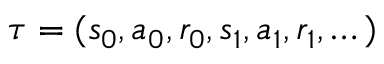<formula> <loc_0><loc_0><loc_500><loc_500>\tau = ( s _ { 0 } , a _ { 0 } , r _ { 0 } , s _ { 1 } , a _ { 1 } , r _ { 1 } , \dots )</formula> 